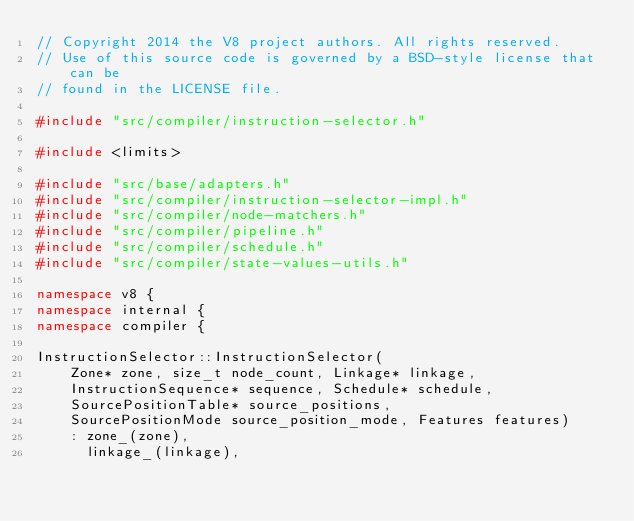Convert code to text. <code><loc_0><loc_0><loc_500><loc_500><_C++_>// Copyright 2014 the V8 project authors. All rights reserved.
// Use of this source code is governed by a BSD-style license that can be
// found in the LICENSE file.

#include "src/compiler/instruction-selector.h"

#include <limits>

#include "src/base/adapters.h"
#include "src/compiler/instruction-selector-impl.h"
#include "src/compiler/node-matchers.h"
#include "src/compiler/pipeline.h"
#include "src/compiler/schedule.h"
#include "src/compiler/state-values-utils.h"

namespace v8 {
namespace internal {
namespace compiler {

InstructionSelector::InstructionSelector(
    Zone* zone, size_t node_count, Linkage* linkage,
    InstructionSequence* sequence, Schedule* schedule,
    SourcePositionTable* source_positions,
    SourcePositionMode source_position_mode, Features features)
    : zone_(zone),
      linkage_(linkage),</code> 